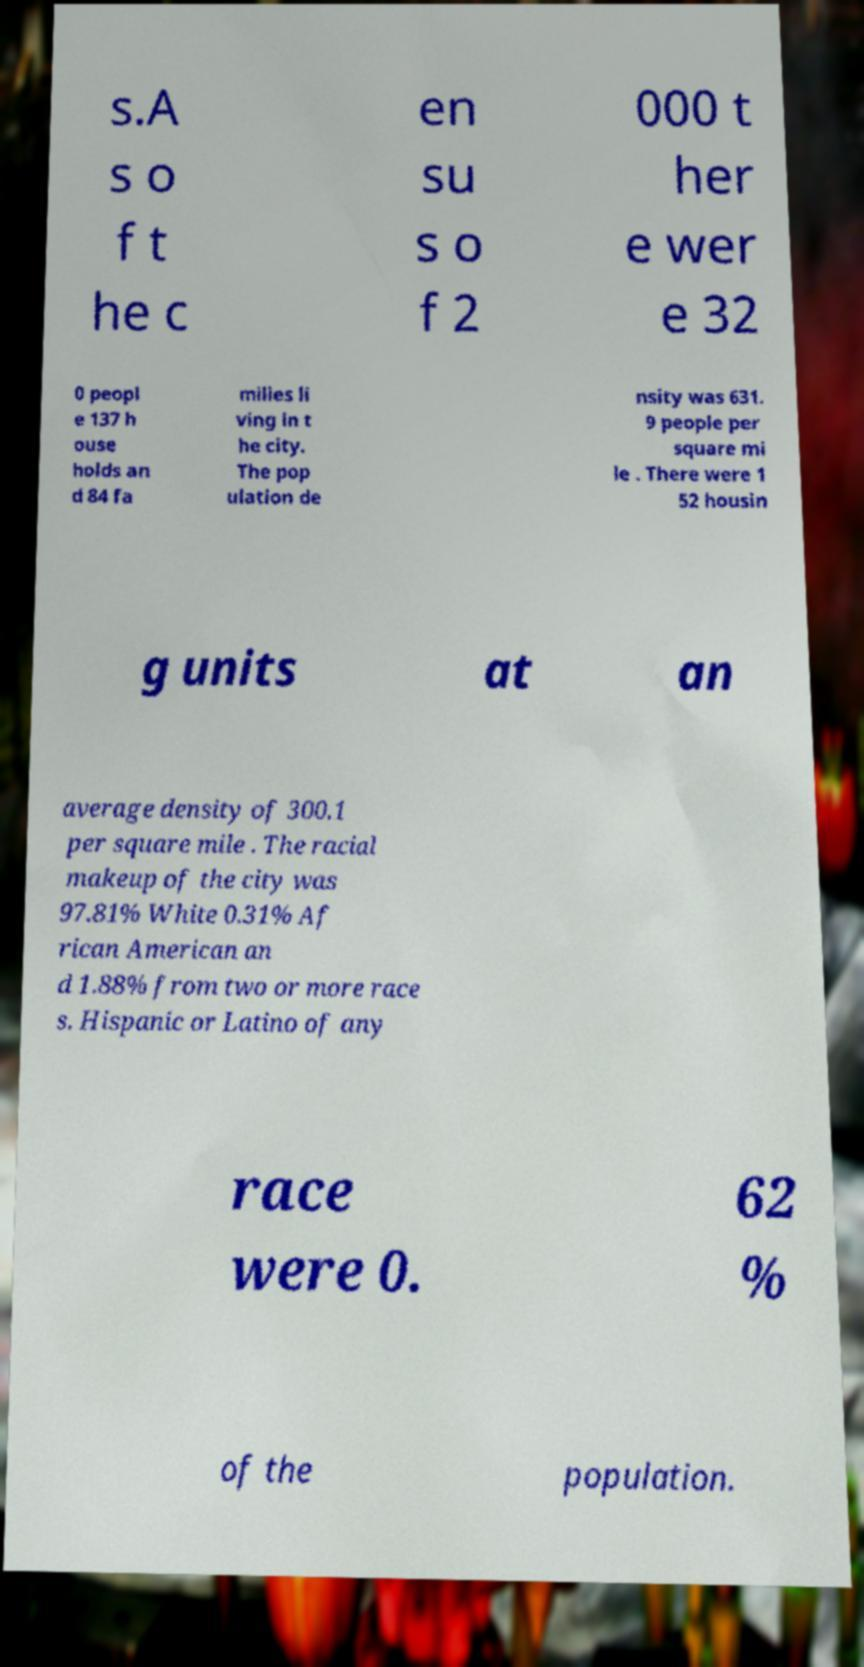Can you accurately transcribe the text from the provided image for me? s.A s o f t he c en su s o f 2 000 t her e wer e 32 0 peopl e 137 h ouse holds an d 84 fa milies li ving in t he city. The pop ulation de nsity was 631. 9 people per square mi le . There were 1 52 housin g units at an average density of 300.1 per square mile . The racial makeup of the city was 97.81% White 0.31% Af rican American an d 1.88% from two or more race s. Hispanic or Latino of any race were 0. 62 % of the population. 